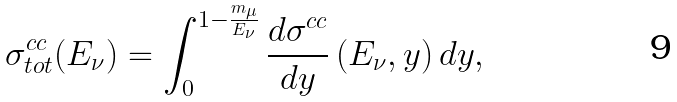Convert formula to latex. <formula><loc_0><loc_0><loc_500><loc_500>\sigma _ { t o t } ^ { c c } ( E _ { \nu } ) = \int _ { 0 } ^ { 1 - \frac { m _ { \mu } } { E _ { \nu } } } \frac { d \sigma ^ { c c } } { d y } \, ( E _ { \nu } , y ) \, d y ,</formula> 